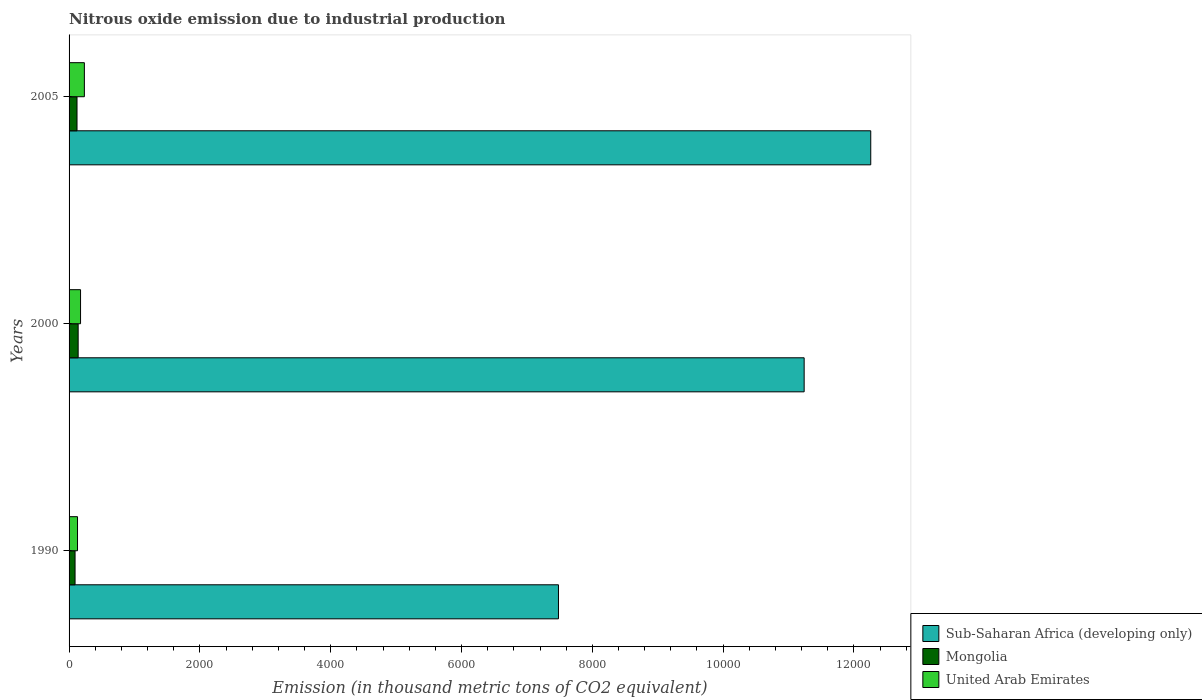How many groups of bars are there?
Your answer should be very brief. 3. Are the number of bars per tick equal to the number of legend labels?
Provide a succinct answer. Yes. How many bars are there on the 3rd tick from the bottom?
Provide a succinct answer. 3. What is the label of the 3rd group of bars from the top?
Your response must be concise. 1990. What is the amount of nitrous oxide emitted in Mongolia in 1990?
Provide a succinct answer. 91.5. Across all years, what is the maximum amount of nitrous oxide emitted in Mongolia?
Your answer should be compact. 138.9. Across all years, what is the minimum amount of nitrous oxide emitted in Mongolia?
Offer a terse response. 91.5. In which year was the amount of nitrous oxide emitted in Sub-Saharan Africa (developing only) maximum?
Provide a succinct answer. 2005. What is the total amount of nitrous oxide emitted in Mongolia in the graph?
Your response must be concise. 351.8. What is the difference between the amount of nitrous oxide emitted in Sub-Saharan Africa (developing only) in 1990 and that in 2000?
Offer a terse response. -3756.4. What is the difference between the amount of nitrous oxide emitted in Mongolia in 1990 and the amount of nitrous oxide emitted in Sub-Saharan Africa (developing only) in 2005?
Provide a short and direct response. -1.22e+04. What is the average amount of nitrous oxide emitted in Mongolia per year?
Give a very brief answer. 117.27. In the year 2000, what is the difference between the amount of nitrous oxide emitted in United Arab Emirates and amount of nitrous oxide emitted in Sub-Saharan Africa (developing only)?
Ensure brevity in your answer.  -1.11e+04. In how many years, is the amount of nitrous oxide emitted in Sub-Saharan Africa (developing only) greater than 10000 thousand metric tons?
Give a very brief answer. 2. What is the ratio of the amount of nitrous oxide emitted in United Arab Emirates in 1990 to that in 2000?
Make the answer very short. 0.74. Is the amount of nitrous oxide emitted in Sub-Saharan Africa (developing only) in 2000 less than that in 2005?
Provide a succinct answer. Yes. What is the difference between the highest and the lowest amount of nitrous oxide emitted in Mongolia?
Your response must be concise. 47.4. In how many years, is the amount of nitrous oxide emitted in United Arab Emirates greater than the average amount of nitrous oxide emitted in United Arab Emirates taken over all years?
Provide a succinct answer. 1. Is the sum of the amount of nitrous oxide emitted in Sub-Saharan Africa (developing only) in 1990 and 2000 greater than the maximum amount of nitrous oxide emitted in Mongolia across all years?
Give a very brief answer. Yes. What does the 3rd bar from the top in 2000 represents?
Give a very brief answer. Sub-Saharan Africa (developing only). What does the 1st bar from the bottom in 1990 represents?
Your answer should be compact. Sub-Saharan Africa (developing only). Is it the case that in every year, the sum of the amount of nitrous oxide emitted in Sub-Saharan Africa (developing only) and amount of nitrous oxide emitted in Mongolia is greater than the amount of nitrous oxide emitted in United Arab Emirates?
Your answer should be very brief. Yes. How many bars are there?
Your answer should be compact. 9. How many years are there in the graph?
Provide a succinct answer. 3. What is the difference between two consecutive major ticks on the X-axis?
Your response must be concise. 2000. Are the values on the major ticks of X-axis written in scientific E-notation?
Your answer should be compact. No. How many legend labels are there?
Provide a short and direct response. 3. How are the legend labels stacked?
Ensure brevity in your answer.  Vertical. What is the title of the graph?
Your answer should be very brief. Nitrous oxide emission due to industrial production. What is the label or title of the X-axis?
Offer a terse response. Emission (in thousand metric tons of CO2 equivalent). What is the Emission (in thousand metric tons of CO2 equivalent) in Sub-Saharan Africa (developing only) in 1990?
Your response must be concise. 7482.3. What is the Emission (in thousand metric tons of CO2 equivalent) in Mongolia in 1990?
Give a very brief answer. 91.5. What is the Emission (in thousand metric tons of CO2 equivalent) in United Arab Emirates in 1990?
Your answer should be very brief. 129.2. What is the Emission (in thousand metric tons of CO2 equivalent) in Sub-Saharan Africa (developing only) in 2000?
Offer a very short reply. 1.12e+04. What is the Emission (in thousand metric tons of CO2 equivalent) of Mongolia in 2000?
Make the answer very short. 138.9. What is the Emission (in thousand metric tons of CO2 equivalent) of United Arab Emirates in 2000?
Provide a short and direct response. 175.5. What is the Emission (in thousand metric tons of CO2 equivalent) in Sub-Saharan Africa (developing only) in 2005?
Your answer should be very brief. 1.23e+04. What is the Emission (in thousand metric tons of CO2 equivalent) in Mongolia in 2005?
Keep it short and to the point. 121.4. What is the Emission (in thousand metric tons of CO2 equivalent) of United Arab Emirates in 2005?
Your response must be concise. 234. Across all years, what is the maximum Emission (in thousand metric tons of CO2 equivalent) of Sub-Saharan Africa (developing only)?
Your answer should be compact. 1.23e+04. Across all years, what is the maximum Emission (in thousand metric tons of CO2 equivalent) in Mongolia?
Offer a very short reply. 138.9. Across all years, what is the maximum Emission (in thousand metric tons of CO2 equivalent) in United Arab Emirates?
Offer a very short reply. 234. Across all years, what is the minimum Emission (in thousand metric tons of CO2 equivalent) of Sub-Saharan Africa (developing only)?
Provide a succinct answer. 7482.3. Across all years, what is the minimum Emission (in thousand metric tons of CO2 equivalent) in Mongolia?
Offer a very short reply. 91.5. Across all years, what is the minimum Emission (in thousand metric tons of CO2 equivalent) of United Arab Emirates?
Ensure brevity in your answer.  129.2. What is the total Emission (in thousand metric tons of CO2 equivalent) of Sub-Saharan Africa (developing only) in the graph?
Offer a very short reply. 3.10e+04. What is the total Emission (in thousand metric tons of CO2 equivalent) in Mongolia in the graph?
Give a very brief answer. 351.8. What is the total Emission (in thousand metric tons of CO2 equivalent) of United Arab Emirates in the graph?
Give a very brief answer. 538.7. What is the difference between the Emission (in thousand metric tons of CO2 equivalent) in Sub-Saharan Africa (developing only) in 1990 and that in 2000?
Your answer should be compact. -3756.4. What is the difference between the Emission (in thousand metric tons of CO2 equivalent) in Mongolia in 1990 and that in 2000?
Your answer should be very brief. -47.4. What is the difference between the Emission (in thousand metric tons of CO2 equivalent) in United Arab Emirates in 1990 and that in 2000?
Your response must be concise. -46.3. What is the difference between the Emission (in thousand metric tons of CO2 equivalent) of Sub-Saharan Africa (developing only) in 1990 and that in 2005?
Offer a terse response. -4774.5. What is the difference between the Emission (in thousand metric tons of CO2 equivalent) in Mongolia in 1990 and that in 2005?
Make the answer very short. -29.9. What is the difference between the Emission (in thousand metric tons of CO2 equivalent) in United Arab Emirates in 1990 and that in 2005?
Keep it short and to the point. -104.8. What is the difference between the Emission (in thousand metric tons of CO2 equivalent) in Sub-Saharan Africa (developing only) in 2000 and that in 2005?
Provide a succinct answer. -1018.1. What is the difference between the Emission (in thousand metric tons of CO2 equivalent) of United Arab Emirates in 2000 and that in 2005?
Give a very brief answer. -58.5. What is the difference between the Emission (in thousand metric tons of CO2 equivalent) of Sub-Saharan Africa (developing only) in 1990 and the Emission (in thousand metric tons of CO2 equivalent) of Mongolia in 2000?
Offer a very short reply. 7343.4. What is the difference between the Emission (in thousand metric tons of CO2 equivalent) of Sub-Saharan Africa (developing only) in 1990 and the Emission (in thousand metric tons of CO2 equivalent) of United Arab Emirates in 2000?
Your answer should be compact. 7306.8. What is the difference between the Emission (in thousand metric tons of CO2 equivalent) of Mongolia in 1990 and the Emission (in thousand metric tons of CO2 equivalent) of United Arab Emirates in 2000?
Your answer should be compact. -84. What is the difference between the Emission (in thousand metric tons of CO2 equivalent) of Sub-Saharan Africa (developing only) in 1990 and the Emission (in thousand metric tons of CO2 equivalent) of Mongolia in 2005?
Offer a terse response. 7360.9. What is the difference between the Emission (in thousand metric tons of CO2 equivalent) in Sub-Saharan Africa (developing only) in 1990 and the Emission (in thousand metric tons of CO2 equivalent) in United Arab Emirates in 2005?
Offer a very short reply. 7248.3. What is the difference between the Emission (in thousand metric tons of CO2 equivalent) of Mongolia in 1990 and the Emission (in thousand metric tons of CO2 equivalent) of United Arab Emirates in 2005?
Provide a short and direct response. -142.5. What is the difference between the Emission (in thousand metric tons of CO2 equivalent) of Sub-Saharan Africa (developing only) in 2000 and the Emission (in thousand metric tons of CO2 equivalent) of Mongolia in 2005?
Your answer should be very brief. 1.11e+04. What is the difference between the Emission (in thousand metric tons of CO2 equivalent) in Sub-Saharan Africa (developing only) in 2000 and the Emission (in thousand metric tons of CO2 equivalent) in United Arab Emirates in 2005?
Ensure brevity in your answer.  1.10e+04. What is the difference between the Emission (in thousand metric tons of CO2 equivalent) in Mongolia in 2000 and the Emission (in thousand metric tons of CO2 equivalent) in United Arab Emirates in 2005?
Your response must be concise. -95.1. What is the average Emission (in thousand metric tons of CO2 equivalent) of Sub-Saharan Africa (developing only) per year?
Offer a terse response. 1.03e+04. What is the average Emission (in thousand metric tons of CO2 equivalent) in Mongolia per year?
Provide a succinct answer. 117.27. What is the average Emission (in thousand metric tons of CO2 equivalent) in United Arab Emirates per year?
Keep it short and to the point. 179.57. In the year 1990, what is the difference between the Emission (in thousand metric tons of CO2 equivalent) of Sub-Saharan Africa (developing only) and Emission (in thousand metric tons of CO2 equivalent) of Mongolia?
Ensure brevity in your answer.  7390.8. In the year 1990, what is the difference between the Emission (in thousand metric tons of CO2 equivalent) of Sub-Saharan Africa (developing only) and Emission (in thousand metric tons of CO2 equivalent) of United Arab Emirates?
Provide a short and direct response. 7353.1. In the year 1990, what is the difference between the Emission (in thousand metric tons of CO2 equivalent) in Mongolia and Emission (in thousand metric tons of CO2 equivalent) in United Arab Emirates?
Keep it short and to the point. -37.7. In the year 2000, what is the difference between the Emission (in thousand metric tons of CO2 equivalent) of Sub-Saharan Africa (developing only) and Emission (in thousand metric tons of CO2 equivalent) of Mongolia?
Provide a succinct answer. 1.11e+04. In the year 2000, what is the difference between the Emission (in thousand metric tons of CO2 equivalent) in Sub-Saharan Africa (developing only) and Emission (in thousand metric tons of CO2 equivalent) in United Arab Emirates?
Make the answer very short. 1.11e+04. In the year 2000, what is the difference between the Emission (in thousand metric tons of CO2 equivalent) of Mongolia and Emission (in thousand metric tons of CO2 equivalent) of United Arab Emirates?
Offer a very short reply. -36.6. In the year 2005, what is the difference between the Emission (in thousand metric tons of CO2 equivalent) of Sub-Saharan Africa (developing only) and Emission (in thousand metric tons of CO2 equivalent) of Mongolia?
Keep it short and to the point. 1.21e+04. In the year 2005, what is the difference between the Emission (in thousand metric tons of CO2 equivalent) in Sub-Saharan Africa (developing only) and Emission (in thousand metric tons of CO2 equivalent) in United Arab Emirates?
Your answer should be compact. 1.20e+04. In the year 2005, what is the difference between the Emission (in thousand metric tons of CO2 equivalent) of Mongolia and Emission (in thousand metric tons of CO2 equivalent) of United Arab Emirates?
Provide a succinct answer. -112.6. What is the ratio of the Emission (in thousand metric tons of CO2 equivalent) of Sub-Saharan Africa (developing only) in 1990 to that in 2000?
Offer a very short reply. 0.67. What is the ratio of the Emission (in thousand metric tons of CO2 equivalent) in Mongolia in 1990 to that in 2000?
Provide a short and direct response. 0.66. What is the ratio of the Emission (in thousand metric tons of CO2 equivalent) of United Arab Emirates in 1990 to that in 2000?
Give a very brief answer. 0.74. What is the ratio of the Emission (in thousand metric tons of CO2 equivalent) of Sub-Saharan Africa (developing only) in 1990 to that in 2005?
Keep it short and to the point. 0.61. What is the ratio of the Emission (in thousand metric tons of CO2 equivalent) of Mongolia in 1990 to that in 2005?
Provide a short and direct response. 0.75. What is the ratio of the Emission (in thousand metric tons of CO2 equivalent) of United Arab Emirates in 1990 to that in 2005?
Your answer should be very brief. 0.55. What is the ratio of the Emission (in thousand metric tons of CO2 equivalent) of Sub-Saharan Africa (developing only) in 2000 to that in 2005?
Provide a short and direct response. 0.92. What is the ratio of the Emission (in thousand metric tons of CO2 equivalent) in Mongolia in 2000 to that in 2005?
Offer a very short reply. 1.14. What is the ratio of the Emission (in thousand metric tons of CO2 equivalent) in United Arab Emirates in 2000 to that in 2005?
Offer a very short reply. 0.75. What is the difference between the highest and the second highest Emission (in thousand metric tons of CO2 equivalent) in Sub-Saharan Africa (developing only)?
Your answer should be very brief. 1018.1. What is the difference between the highest and the second highest Emission (in thousand metric tons of CO2 equivalent) in United Arab Emirates?
Your response must be concise. 58.5. What is the difference between the highest and the lowest Emission (in thousand metric tons of CO2 equivalent) of Sub-Saharan Africa (developing only)?
Offer a terse response. 4774.5. What is the difference between the highest and the lowest Emission (in thousand metric tons of CO2 equivalent) of Mongolia?
Your answer should be very brief. 47.4. What is the difference between the highest and the lowest Emission (in thousand metric tons of CO2 equivalent) of United Arab Emirates?
Give a very brief answer. 104.8. 